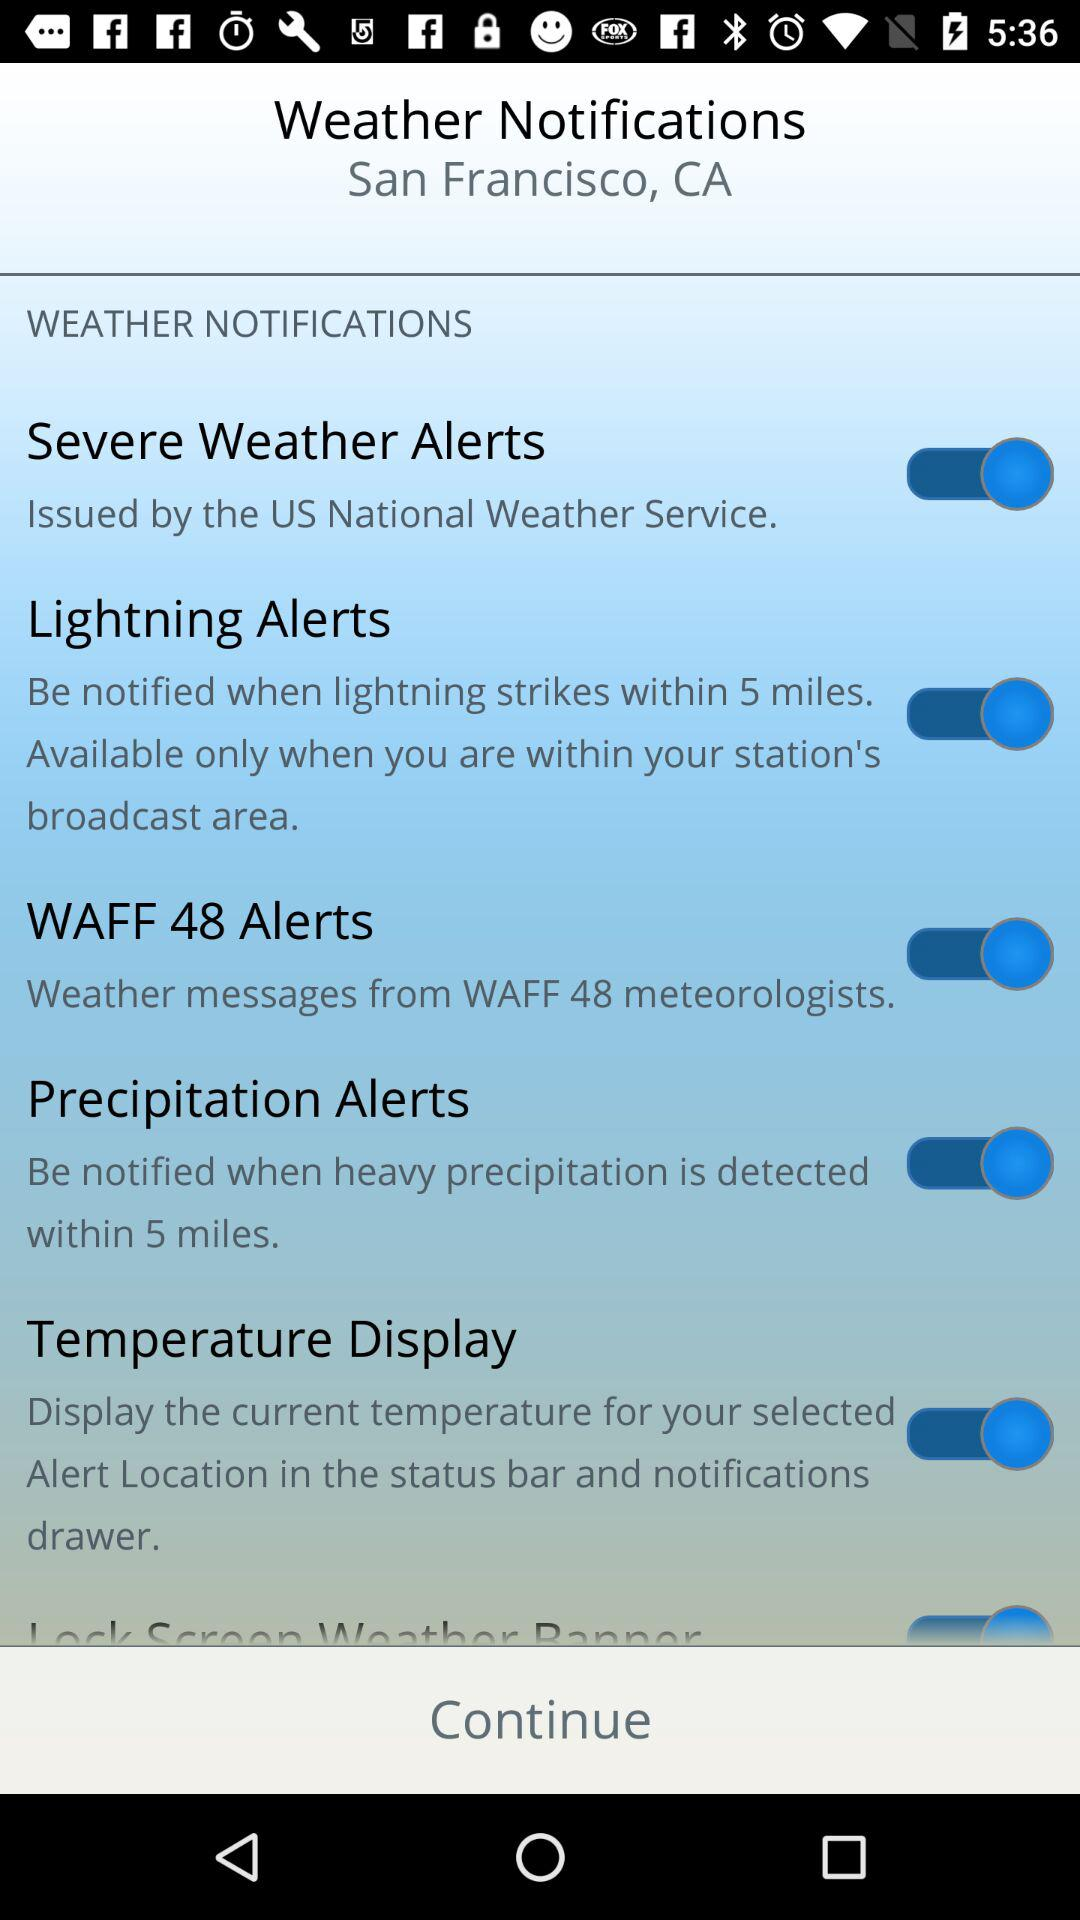What is the status of "Severe Weather Alerts"? The status of "Severe Weather Alerts" is "on". 